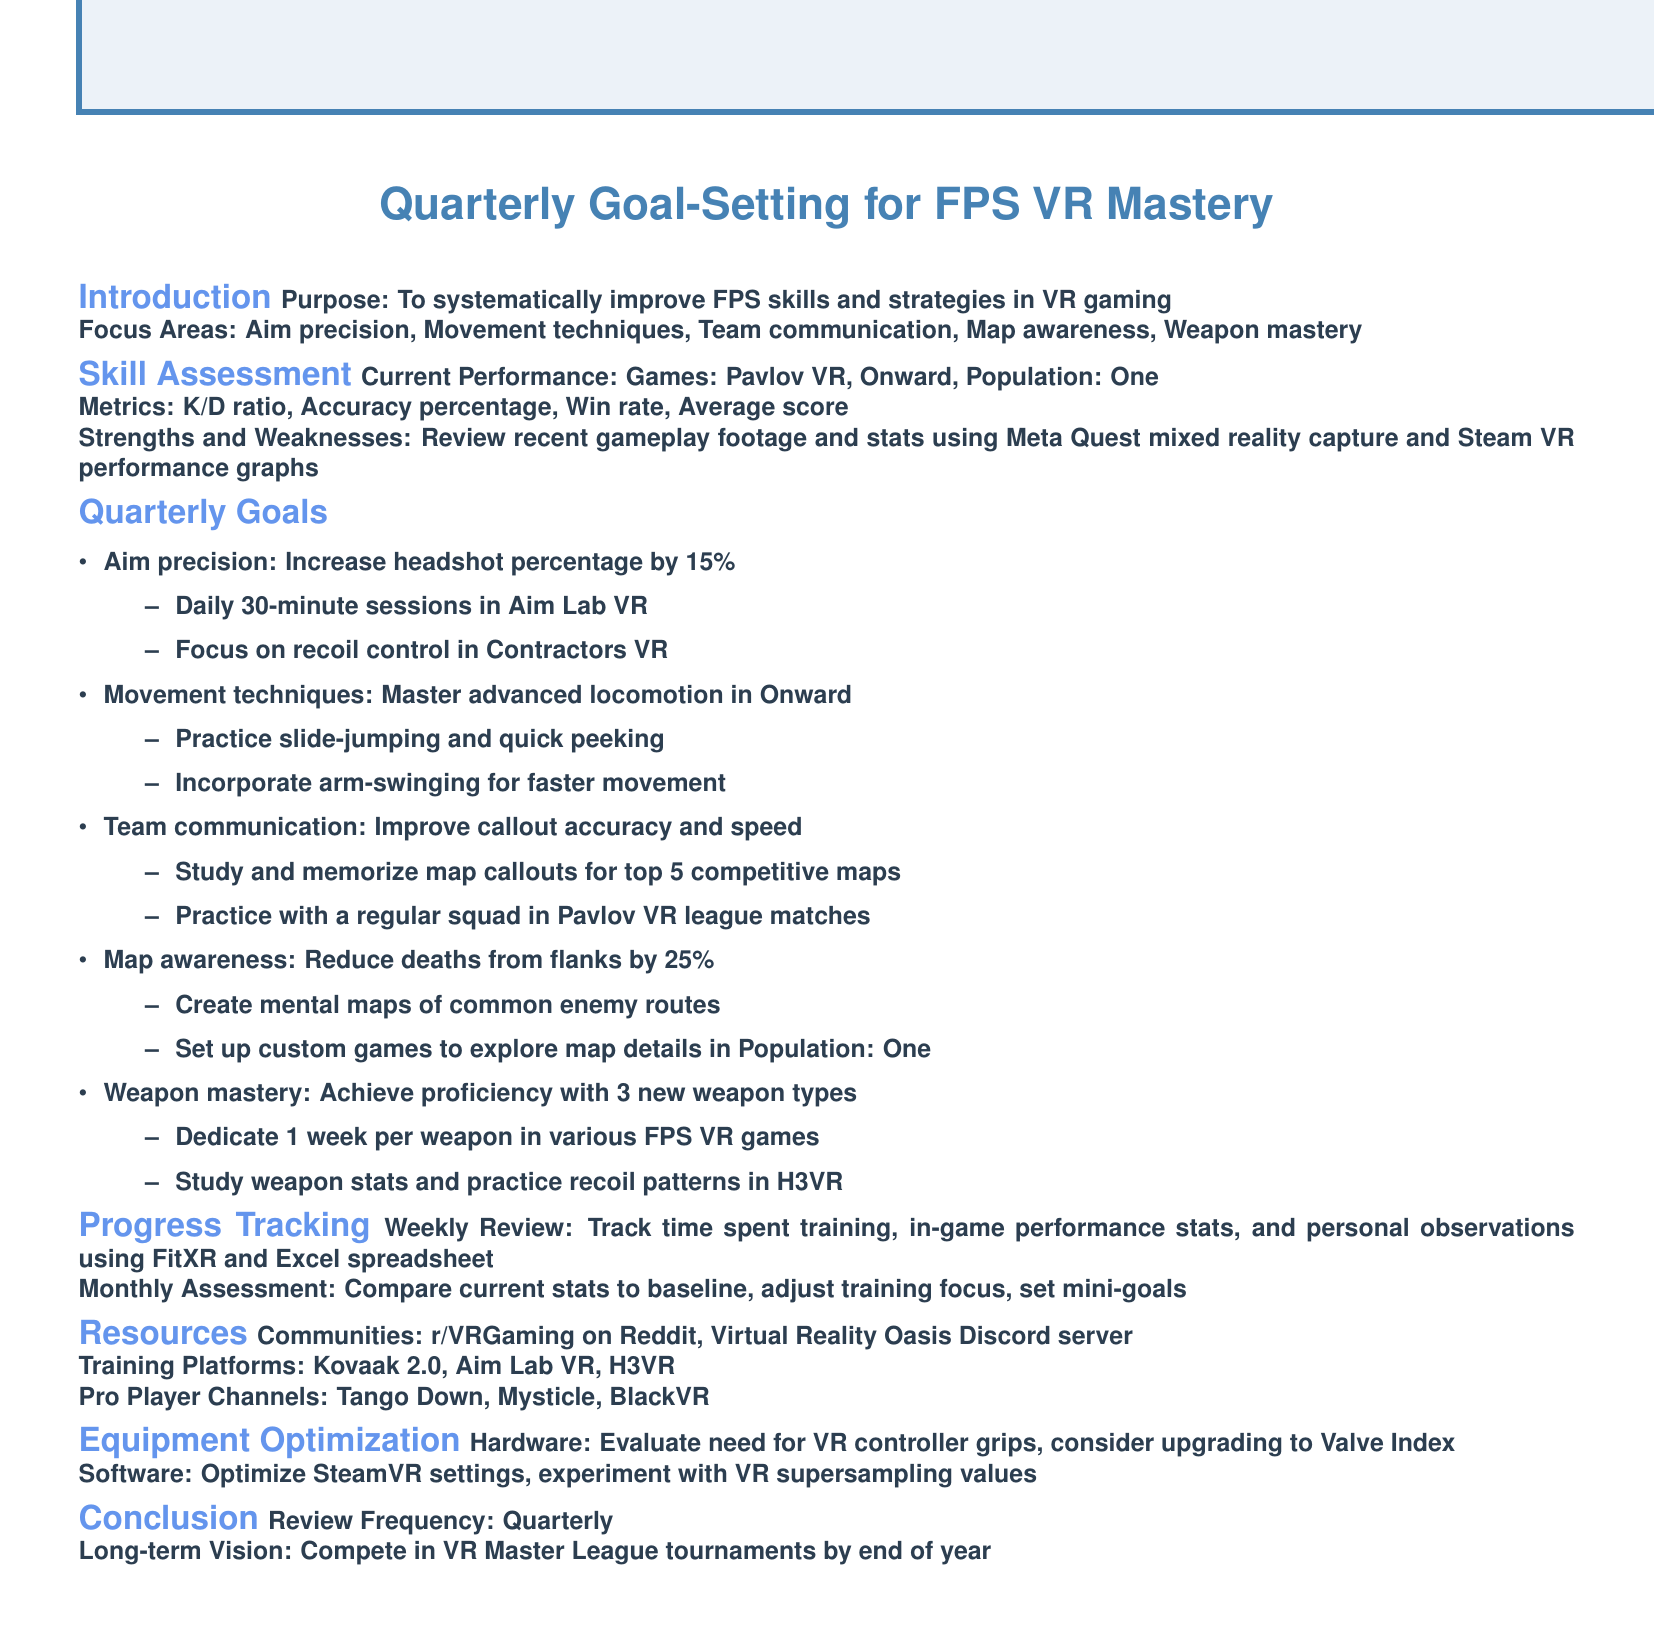What is the agenda title? The agenda title is the main focus of the document, which states the purpose of the goal-setting process.
Answer: Quarterly Goal-Setting for FPS VR Mastery What percentage increase is targeted for headshot accuracy? This asks for a specific performance improvement goal mentioned in the quarterly goals section.
Answer: 15% Which game is mentioned for team communication practice? This refers to the specific game where team communication strategies are to be implemented.
Answer: Pavlov VR How many weapon types does the weapon mastery goal target? This question seeks a specific number related to a goal stated in the document.
Answer: 3 What is the review frequency for the quarterly goals? This relates to how often the goals will be reviewed as per the conclusion section of the document.
Answer: Quarterly What is one tool mentioned for tracking weekly progress? This question asks for a specific tool that is recommended for measuring training progress.
Answer: FitXR Which training platform is listed for aim training? This refers to the specific platform suggested in the resources section for practicing aim skills.
Answer: Aim Lab VR What is the goal for reducing deaths from flanks? The goal mentioned in the map awareness section is stated as a numeric reduction.
Answer: 25% What is the long-term vision by the end of the year? This seeks to identify the ultimate goal to be achieved as discussed in the conclusion of the agenda.
Answer: Compete in VR Master League tournaments 